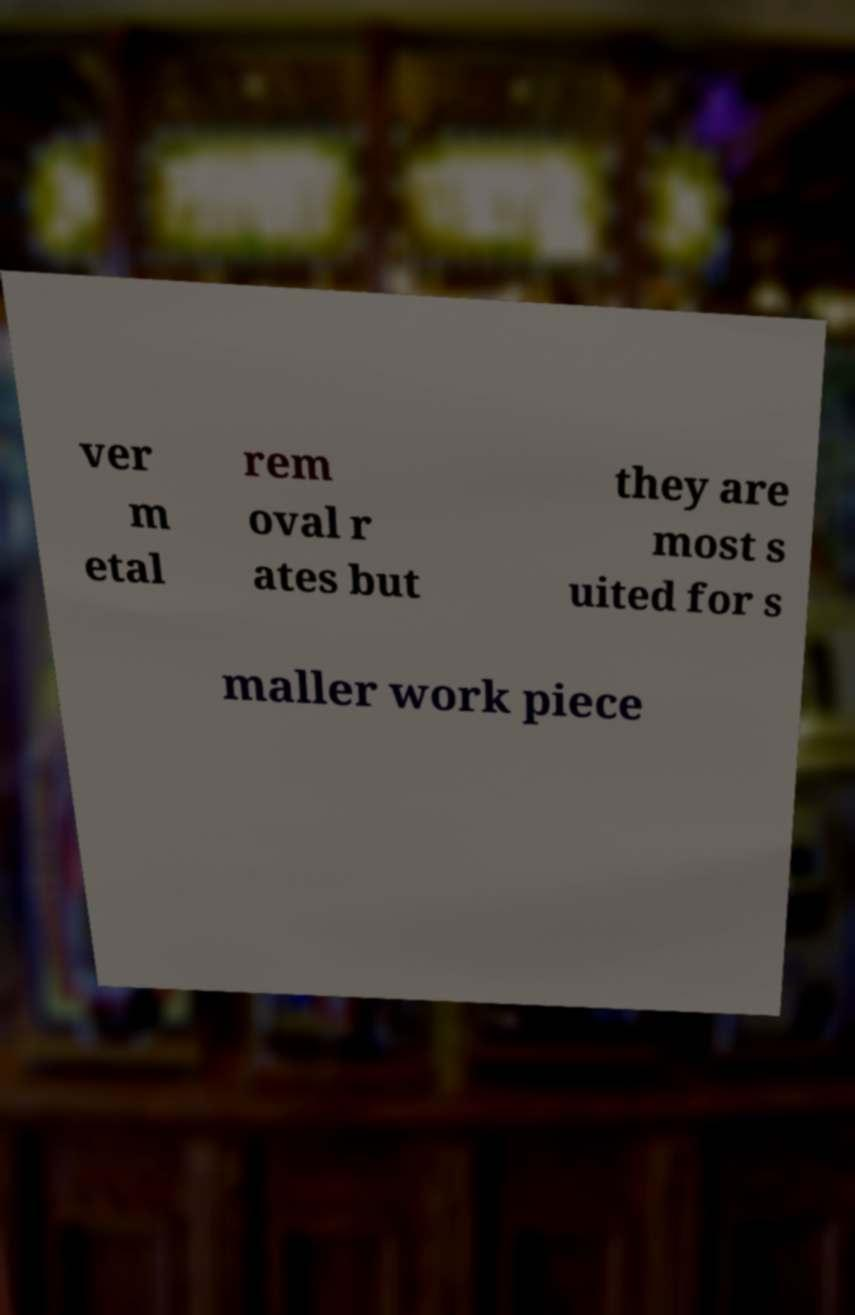Can you accurately transcribe the text from the provided image for me? ver m etal rem oval r ates but they are most s uited for s maller work piece 